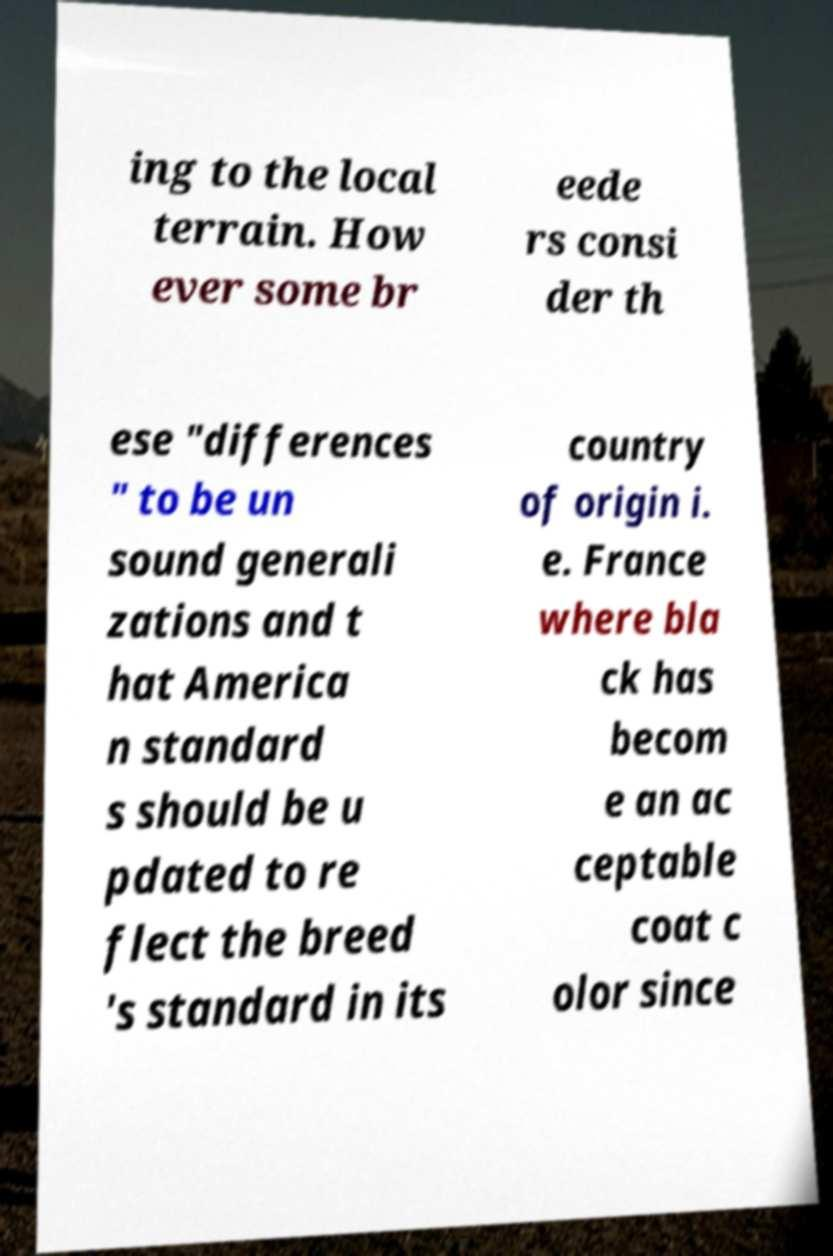Can you read and provide the text displayed in the image?This photo seems to have some interesting text. Can you extract and type it out for me? ing to the local terrain. How ever some br eede rs consi der th ese "differences " to be un sound generali zations and t hat America n standard s should be u pdated to re flect the breed 's standard in its country of origin i. e. France where bla ck has becom e an ac ceptable coat c olor since 